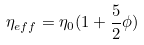<formula> <loc_0><loc_0><loc_500><loc_500>\eta _ { e f f } = \eta _ { 0 } ( 1 + \frac { 5 } { 2 } \phi )</formula> 